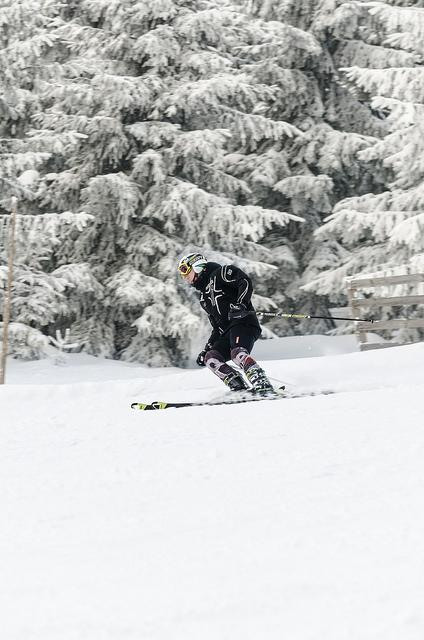Why do skiers wear suits? Please explain your reasoning. snowsuit. They wear them to keep warm and keep the snow off of them. 